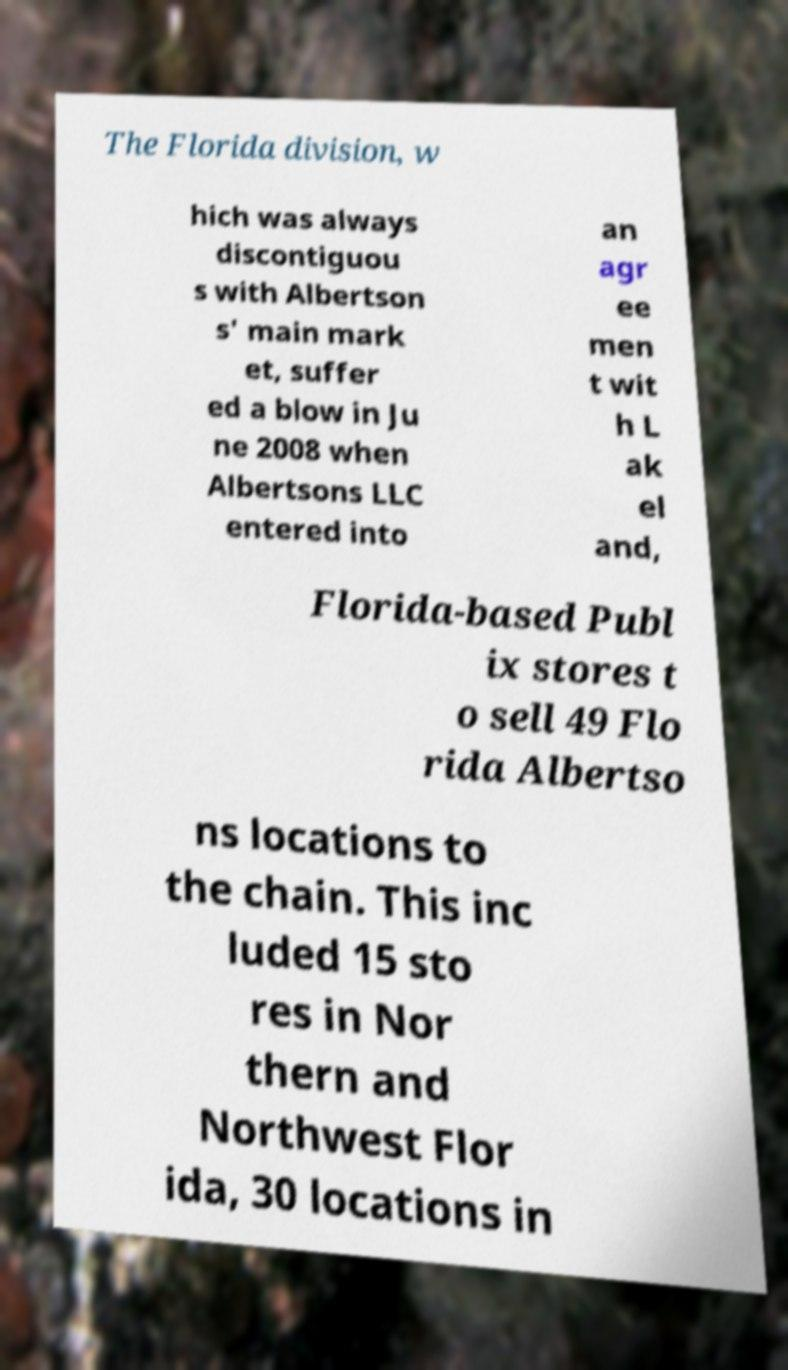For documentation purposes, I need the text within this image transcribed. Could you provide that? The Florida division, w hich was always discontiguou s with Albertson s' main mark et, suffer ed a blow in Ju ne 2008 when Albertsons LLC entered into an agr ee men t wit h L ak el and, Florida-based Publ ix stores t o sell 49 Flo rida Albertso ns locations to the chain. This inc luded 15 sto res in Nor thern and Northwest Flor ida, 30 locations in 